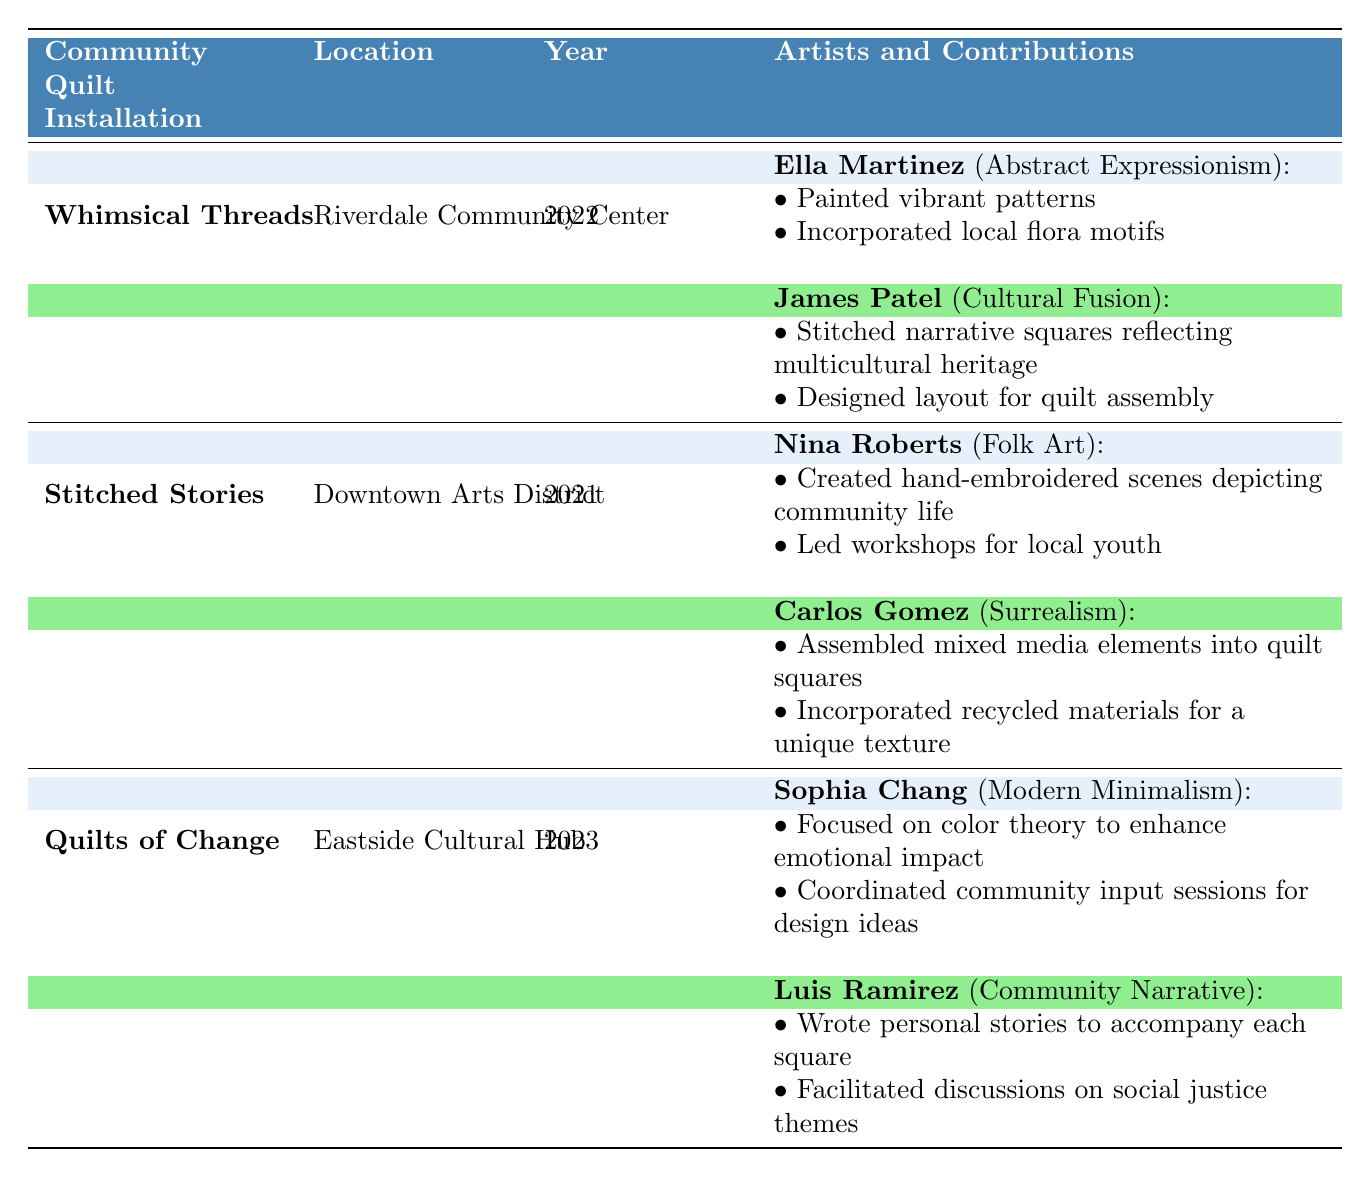What is the location of the "Whimsical Threads" installation? The table indicates under the column "Location" that the installation "Whimsical Threads" is located at the "Riverdale Community Center."
Answer: Riverdale Community Center Who created hand-embroidered scenes for "Stitched Stories"? The table lists under the "Artists and Contributions" section that Nina Roberts created hand-embroidered scenes depicting community life for "Stitched Stories."
Answer: Nina Roberts Is "Luis Ramirez" associated with the "Abstract Expressionism" art style? By checking the "Artists and Contributions" section, it's clear that Luis Ramirez's art style is "Community Narrative," not "Abstract Expressionism." Thus, the answer is no.
Answer: No How many community quilt installations featured artists contributing to social justice themes? In the table, only "Quilts of Change" includes contributions related to social justice themes through Luis Ramirez’s discussions. Therefore, there is one installation.
Answer: 1 Which artist coordinated community input sessions for design ideas? According to the table, under the "Quilts of Change" installation, Sophia Chang is the artist who coordinated community input sessions for design ideas.
Answer: Sophia Chang Was "Carlos Gomez" involved in any quilt installations in 2023? The table shows that Carlos Gomez contributed to "Stitched Stories" in 2021, but there are no mentions of him in the 2023 installation "Quilts of Change." Thus, the answer is no.
Answer: No What were the contributions of James Patel regarding "Whimsical Threads"? The contributions listed for James Patel are: he stitched narrative squares reflecting multicultural heritage and designed the layout for quilt assembly specifically for "Whimsical Threads."
Answer: Stitched narrative squares and designed layout How many artists contributed to the "Quilts of Change" installation? According to the table, there are two artists listed under the "Quilts of Change" installation: Sophia Chang and Luis Ramirez. Therefore, the answer is two.
Answer: 2 Which art style had the most recent community quilt installation in 2023? The installation "Quilts of Change" is listed under the year 2023 and features artists with "Modern Minimalism" for Sophia Chang and "Community Narrative" for Luis Ramirez, making "Modern Minimalism" the latest noted style.
Answer: Modern Minimalism 